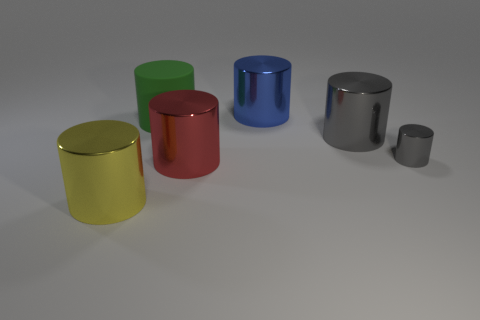Subtract all gray cylinders. How many cylinders are left? 4 Add 3 large yellow cylinders. How many objects exist? 9 Subtract all green cylinders. How many cylinders are left? 5 Subtract 0 gray balls. How many objects are left? 6 Subtract 5 cylinders. How many cylinders are left? 1 Subtract all cyan cylinders. Subtract all cyan cubes. How many cylinders are left? 6 Subtract all gray balls. How many green cylinders are left? 1 Subtract all cylinders. Subtract all large cyan metal things. How many objects are left? 0 Add 2 green objects. How many green objects are left? 3 Add 4 tiny blue matte cylinders. How many tiny blue matte cylinders exist? 4 